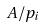<formula> <loc_0><loc_0><loc_500><loc_500>A / p _ { i }</formula> 